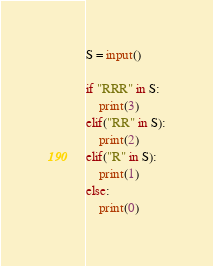Convert code to text. <code><loc_0><loc_0><loc_500><loc_500><_Python_>S = input()

if "RRR" in S:
    print(3)
elif("RR" in S):
    print(2)
elif("R" in S):
    print(1)
else:
    print(0)</code> 